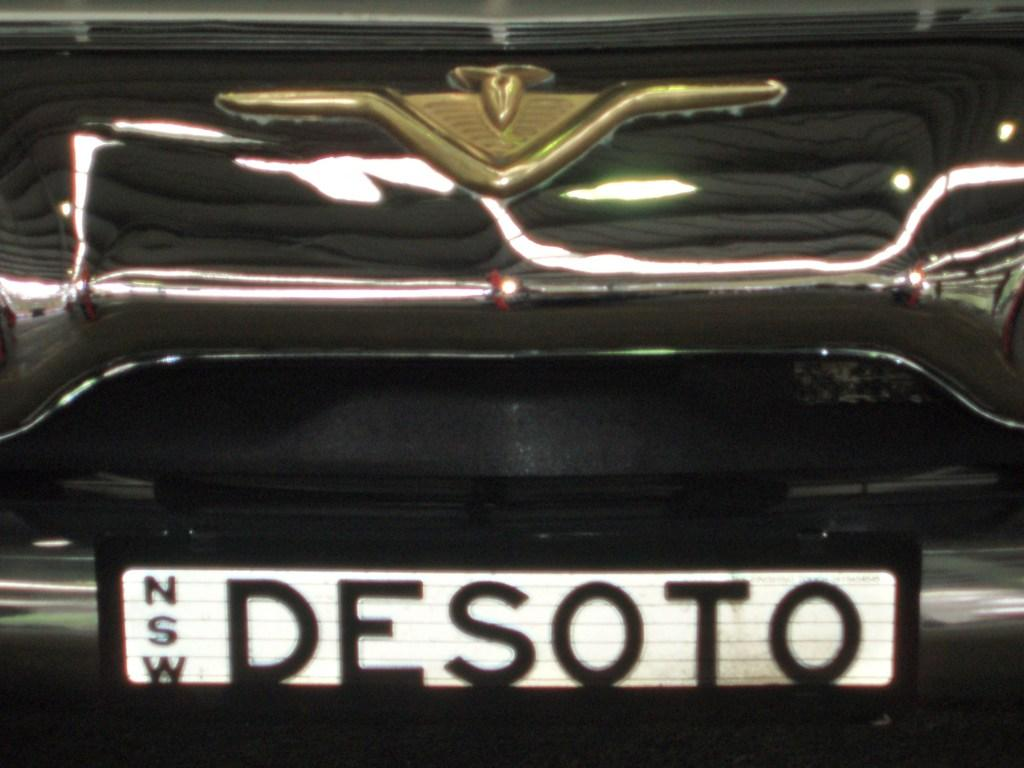Provide a one-sentence caption for the provided image. A black vehicle with Desoto as its license plate. 